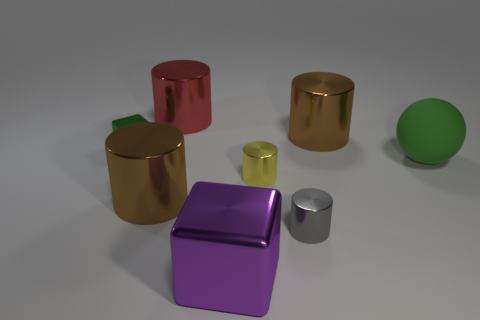Subtract all large red cylinders. How many cylinders are left? 4 Add 1 green shiny spheres. How many objects exist? 9 Subtract all blue balls. How many brown cylinders are left? 2 Subtract all spheres. How many objects are left? 7 Subtract all red cylinders. How many cylinders are left? 4 Subtract 2 cubes. How many cubes are left? 0 Subtract all purple blocks. Subtract all tiny metallic objects. How many objects are left? 4 Add 4 purple things. How many purple things are left? 5 Add 8 gray objects. How many gray objects exist? 9 Subtract 0 gray blocks. How many objects are left? 8 